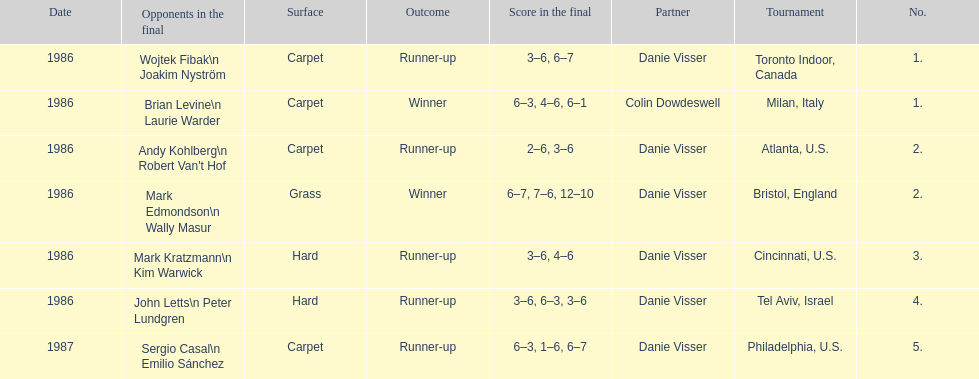What's the total of grass and hard surfaces listed? 3. 